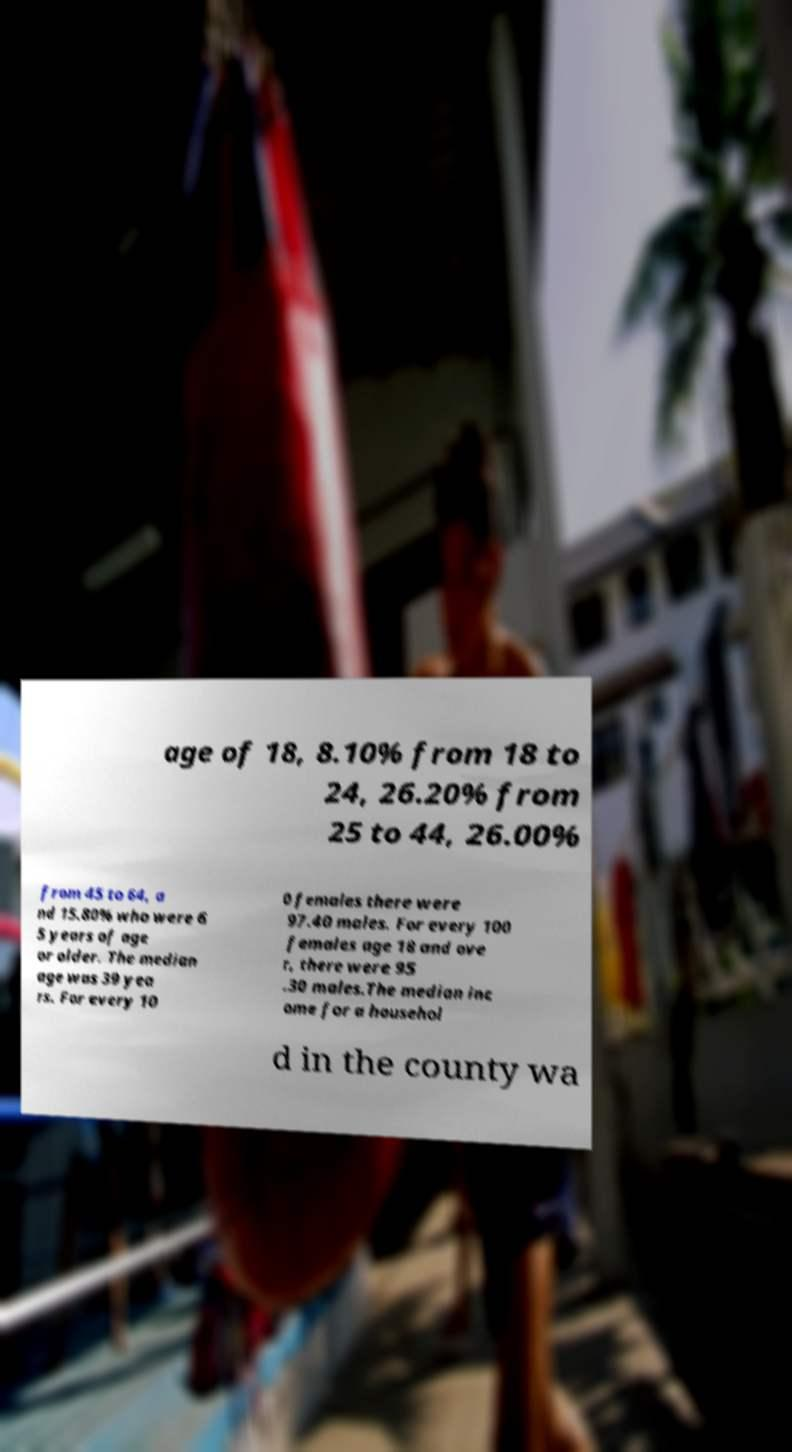Can you accurately transcribe the text from the provided image for me? age of 18, 8.10% from 18 to 24, 26.20% from 25 to 44, 26.00% from 45 to 64, a nd 15.80% who were 6 5 years of age or older. The median age was 39 yea rs. For every 10 0 females there were 97.40 males. For every 100 females age 18 and ove r, there were 95 .30 males.The median inc ome for a househol d in the county wa 